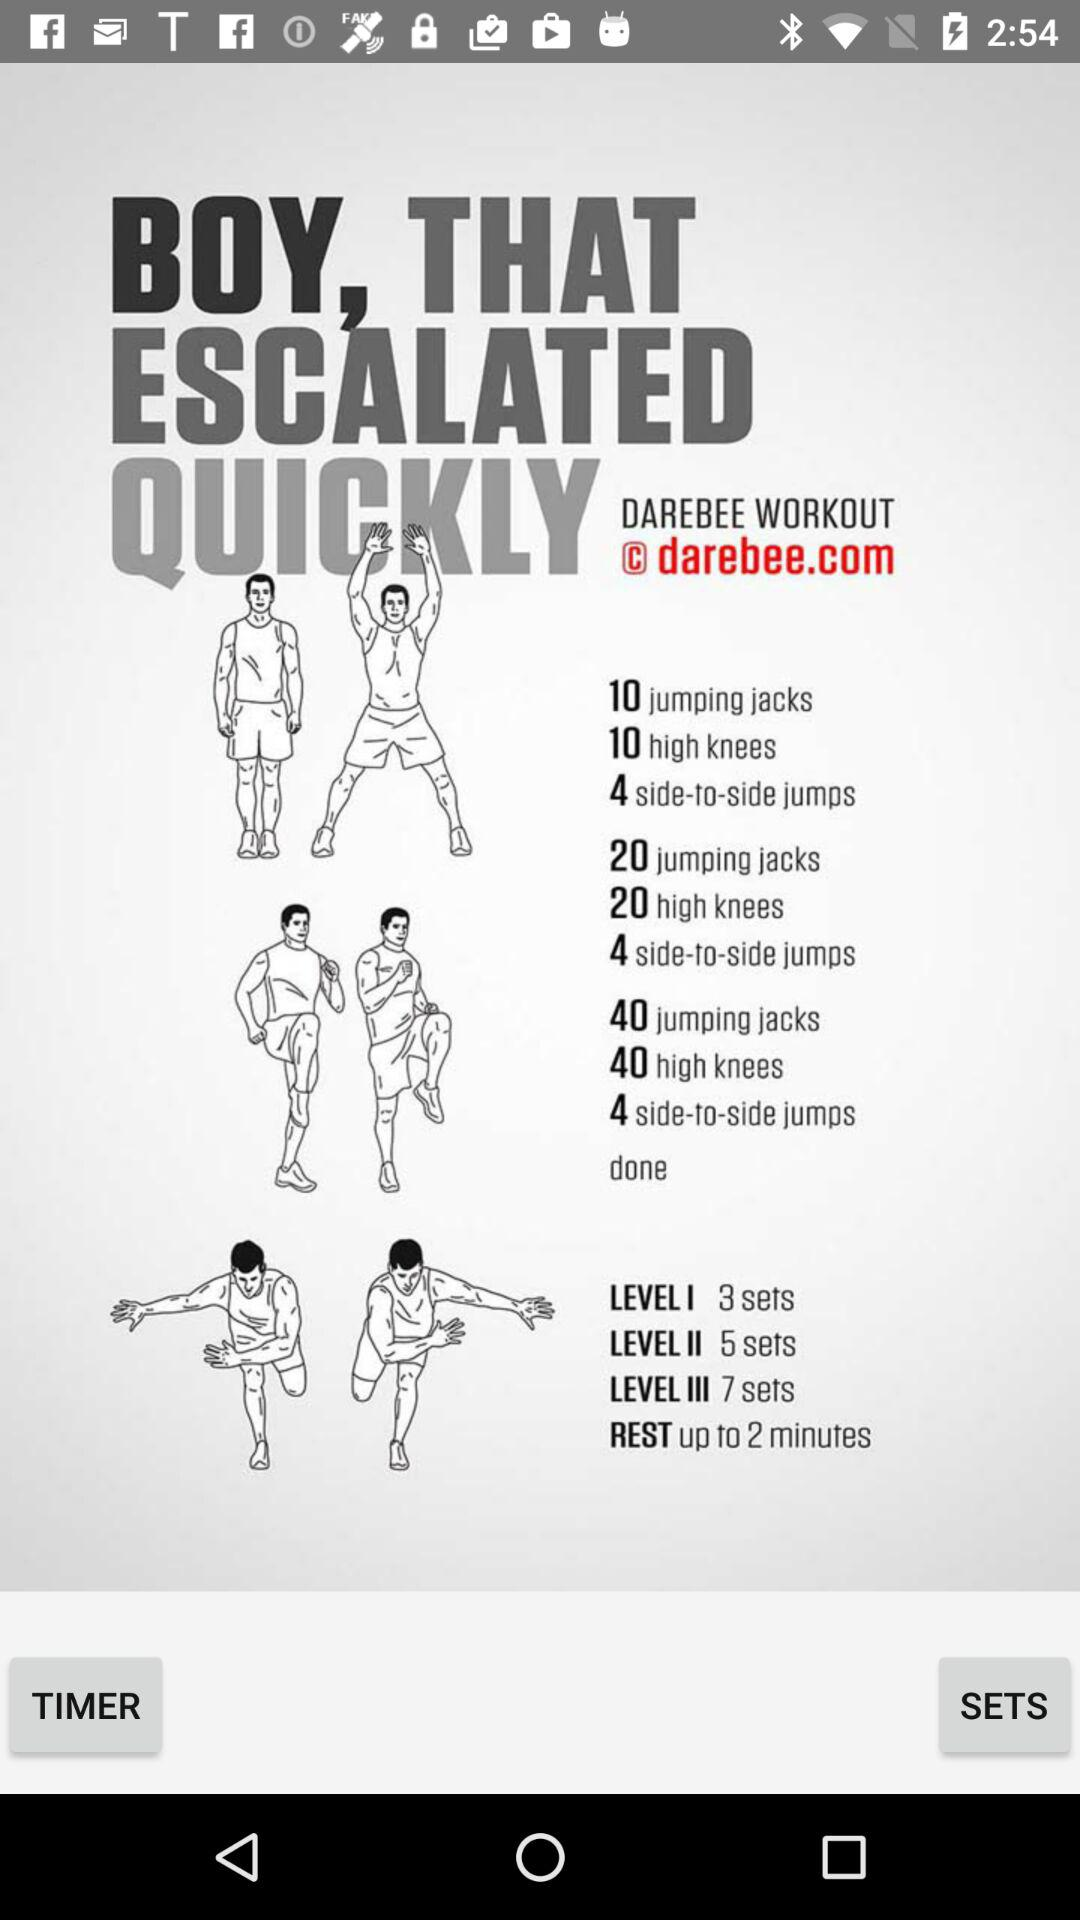How many sets are there in level 2? There are 5 sets in level 2. 